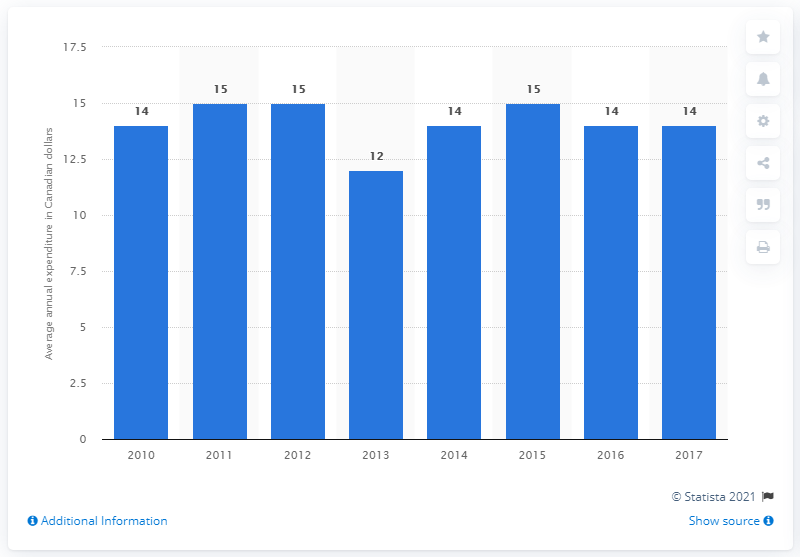What was the average annual household expenditure on microwave ovens in Canada in 2017?
 14 